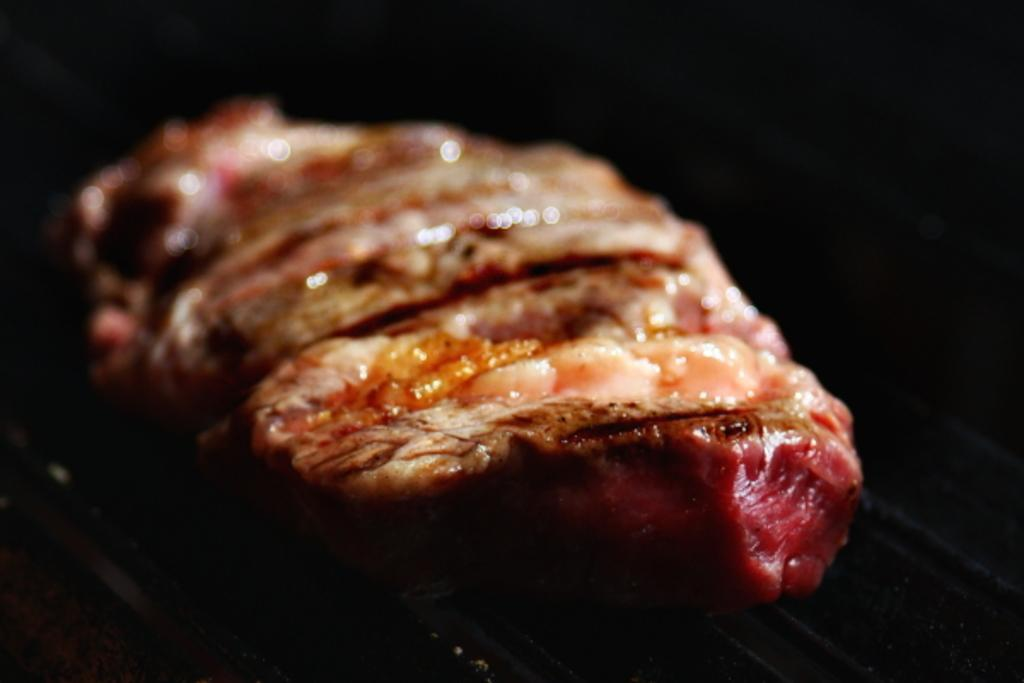What is the main subject of the image? There is a food item in the image. Can you describe the background of the image? The background of the image is dark. What historical event is depicted in the image? There is no historical event depicted in the image; it features a food item with a dark background. What type of lettuce is visible in the image? There is no lettuce present in the image. 